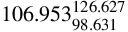Convert formula to latex. <formula><loc_0><loc_0><loc_500><loc_500>1 0 6 . 9 5 3 _ { 9 8 . 6 3 1 } ^ { 1 2 6 . 6 2 7 }</formula> 